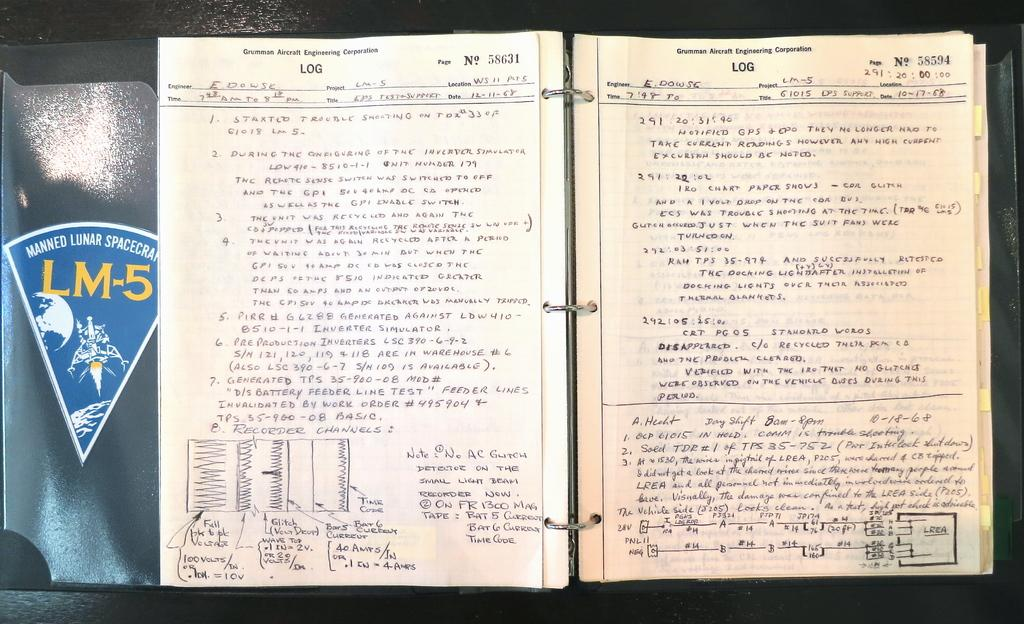Provide a one-sentence caption for the provided image. A notebook is open and is filled with handwritten notes from 1968 for the Grumman Aircraft Engineering Corporation Log. 